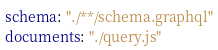<code> <loc_0><loc_0><loc_500><loc_500><_YAML_>schema: "./**/schema.graphql"
documents: "./query.js"
</code> 